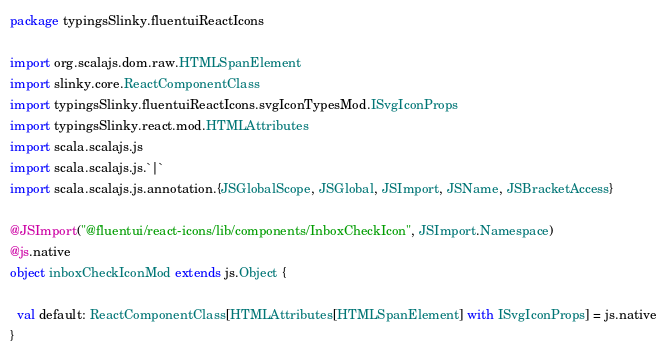<code> <loc_0><loc_0><loc_500><loc_500><_Scala_>package typingsSlinky.fluentuiReactIcons

import org.scalajs.dom.raw.HTMLSpanElement
import slinky.core.ReactComponentClass
import typingsSlinky.fluentuiReactIcons.svgIconTypesMod.ISvgIconProps
import typingsSlinky.react.mod.HTMLAttributes
import scala.scalajs.js
import scala.scalajs.js.`|`
import scala.scalajs.js.annotation.{JSGlobalScope, JSGlobal, JSImport, JSName, JSBracketAccess}

@JSImport("@fluentui/react-icons/lib/components/InboxCheckIcon", JSImport.Namespace)
@js.native
object inboxCheckIconMod extends js.Object {
  
  val default: ReactComponentClass[HTMLAttributes[HTMLSpanElement] with ISvgIconProps] = js.native
}
</code> 